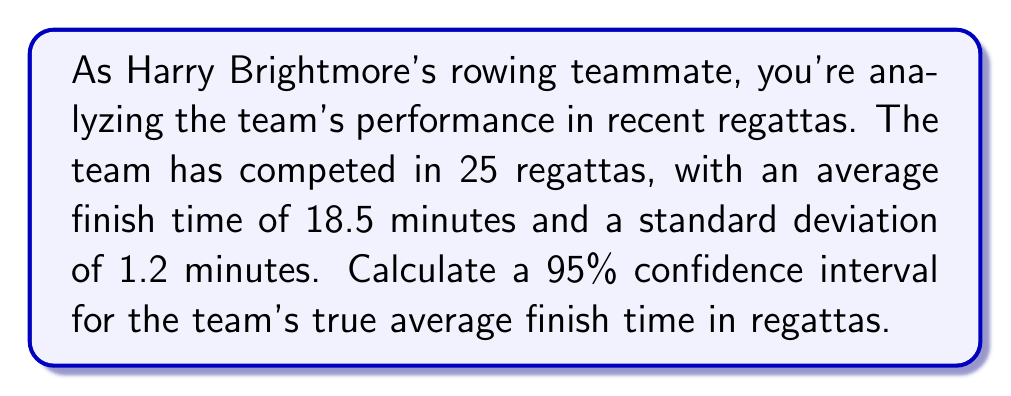Could you help me with this problem? To compute the confidence interval, we'll follow these steps:

1) We're given:
   - Sample size: $n = 25$
   - Sample mean: $\bar{x} = 18.5$ minutes
   - Sample standard deviation: $s = 1.2$ minutes
   - Confidence level: 95%

2) For a 95% confidence interval, we use a $t$-distribution with $n-1 = 24$ degrees of freedom.
   The critical value is $t_{0.025, 24} = 2.064$ (from t-table or calculator)

3) The formula for the confidence interval is:

   $$\bar{x} \pm t_{\alpha/2, n-1} \cdot \frac{s}{\sqrt{n}}$$

4) Calculate the margin of error:

   $$\text{Margin of Error} = t_{\alpha/2, n-1} \cdot \frac{s}{\sqrt{n}} = 2.064 \cdot \frac{1.2}{\sqrt{25}} = 0.495$$

5) Calculate the lower and upper bounds of the confidence interval:

   Lower bound: $18.5 - 0.495 = 18.005$
   Upper bound: $18.5 + 0.495 = 18.995$

6) Round to two decimal places for practical interpretation.
Answer: (18.01, 18.99) minutes 